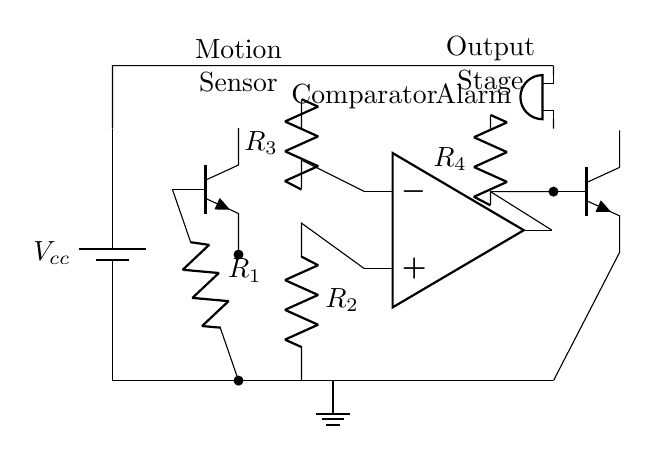What is the main component that detects motion? The main component responsible for detecting motion in the circuit is the motion sensor located at the top left, indicated by the label.
Answer: Motion sensor What type of output signal does the comparator provide? The comparator in the circuit processes the input signals and provides a binary output, which can either trigger the subsequent output stage or keep it off, based on the comparison.
Answer: Binary How many resistors are present in this circuit? The diagram displays a total of four resistors, labeled as R1, R2, R3, and R4.
Answer: Four What is the role of the buzzer in this circuit? The buzzer serves as the alarm indicator that activates upon detection of motion, alerting users to potential activity.
Answer: Alarm What connects the motion sensor to the comparator? The output from the motion sensor is connected to the non-inverting input of the comparator through a resistor, allowing the sensor signal to influence the comparator's operation.
Answer: Resistor What component amplifies the signal in this circuit? The operational amplifier, shown in the middle labeled as comparator, is the component that amplifies the difference between the two input signals around it.
Answer: Operational amplifier What happens to the alarm if no motion is detected? If no motion is detected, the circuit remains inactive, meaning the buzzer will not sound and the output stage will remain off.
Answer: Inactive 